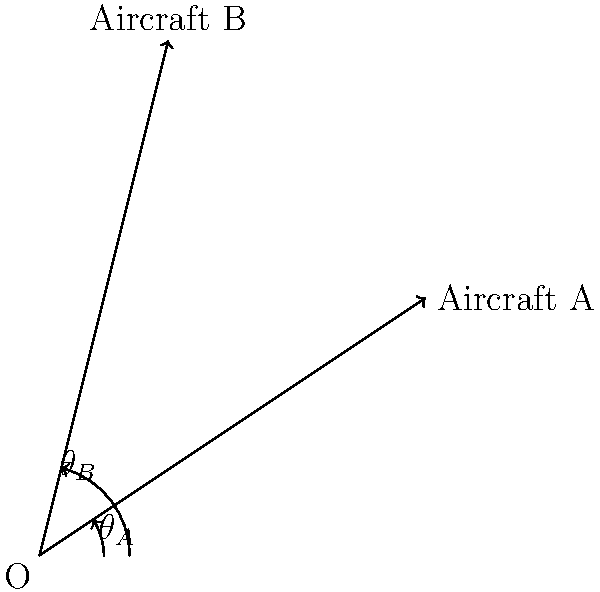As an air traffic controller at a Virginia airport, you're monitoring two aircraft. Aircraft A is at a bearing of $\theta_A = 33.7°$ and distance of 3.61 nautical miles from your position. Aircraft B is at a bearing of $\theta_B = 76.0°$ and distance of 4.12 nautical miles. What is the relative bearing of Aircraft B as seen from Aircraft A? To solve this problem, we'll use vector addition and subtraction. Let's break it down step-by-step:

1) First, convert the polar coordinates (distance and bearing) to Cartesian coordinates:

   Aircraft A: $x_A = 3.61 \cos(33.7°)$, $y_A = 3.61 \sin(33.7°)$
   Aircraft B: $x_B = 4.12 \cos(76.0°)$, $y_B = 4.12 \sin(76.0°)$

2) Calculate the coordinates:
   A: $(3.00, 2.00)$
   B: $(1.00, 4.00)$

3) The vector from A to B is given by subtracting A's coordinates from B's:
   $\vec{AB} = (x_B - x_A, y_B - y_A) = (1.00 - 3.00, 4.00 - 2.00) = (-2.00, 2.00)$

4) To find the bearing, we need to calculate the arctangent of this vector:
   $\theta = \arctan(\frac{y}{x}) = \arctan(\frac{2.00}{-2.00}) = -45°$

5) However, arctan only gives values from $-90°$ to $90°$. Since x is negative and y is positive, we need to add 180° to get the correct quadrant:
   $-45° + 180° = 135°$

6) This is the relative bearing of B from A's perspective.
Answer: 135° 